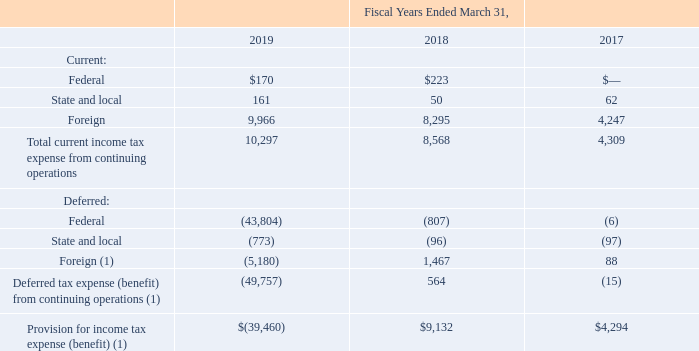Note 11: Income Taxes
The provision for income tax expense (benefit) is as follows (amounts in thousands):
(1) Fiscal years ended March 31, 2018 and 2017 adjusted due to the adoption of ASC 606.
The Company realized a deferred tax expense (benefit) for fiscal years ended 2019, 2018 and 2017 of ($50.1) million, $0.6 million and $1.2 million, respectively, in U.S. and certain foreign jurisdictions based on changes in judgment about the realizability of deferred tax assets in future years.
How much was the deferred tax expense (benefit) in 2017? $1.2 million. What was the current federal income tax expense(benefit) in 2019?
Answer scale should be: thousand. 170. What was the current State and Local income tax expense (benefit) in 2017?
Answer scale should be: thousand. 62. How many years did Total current income tax expense from continuing operations exceed $10,000 thousand? 2019
Answer: 1. What was the change in current foreign income tax expense between 2017 and 2018?
Answer scale should be: thousand. 8,295-4,247
Answer: 4048. What was the percentage change in the deferred federal income tax expense between 2018 and 2019?
Answer scale should be: percent. (-43,804-(-807))/-807
Answer: 5328. 